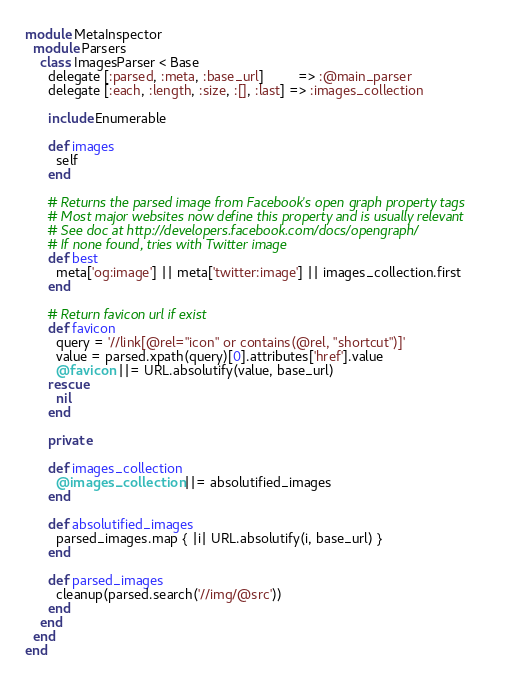Convert code to text. <code><loc_0><loc_0><loc_500><loc_500><_Ruby_>module MetaInspector
  module Parsers
    class ImagesParser < Base
      delegate [:parsed, :meta, :base_url]         => :@main_parser
      delegate [:each, :length, :size, :[], :last] => :images_collection

      include Enumerable

      def images
        self
      end

      # Returns the parsed image from Facebook's open graph property tags
      # Most major websites now define this property and is usually relevant
      # See doc at http://developers.facebook.com/docs/opengraph/
      # If none found, tries with Twitter image
      def best
        meta['og:image'] || meta['twitter:image'] || images_collection.first
      end

      # Return favicon url if exist
      def favicon
        query = '//link[@rel="icon" or contains(@rel, "shortcut")]'
        value = parsed.xpath(query)[0].attributes['href'].value
        @favicon ||= URL.absolutify(value, base_url)
      rescue
        nil
      end

      private

      def images_collection
        @images_collection ||= absolutified_images
      end

      def absolutified_images
        parsed_images.map { |i| URL.absolutify(i, base_url) }
      end

      def parsed_images
        cleanup(parsed.search('//img/@src'))
      end
    end
  end
end
</code> 